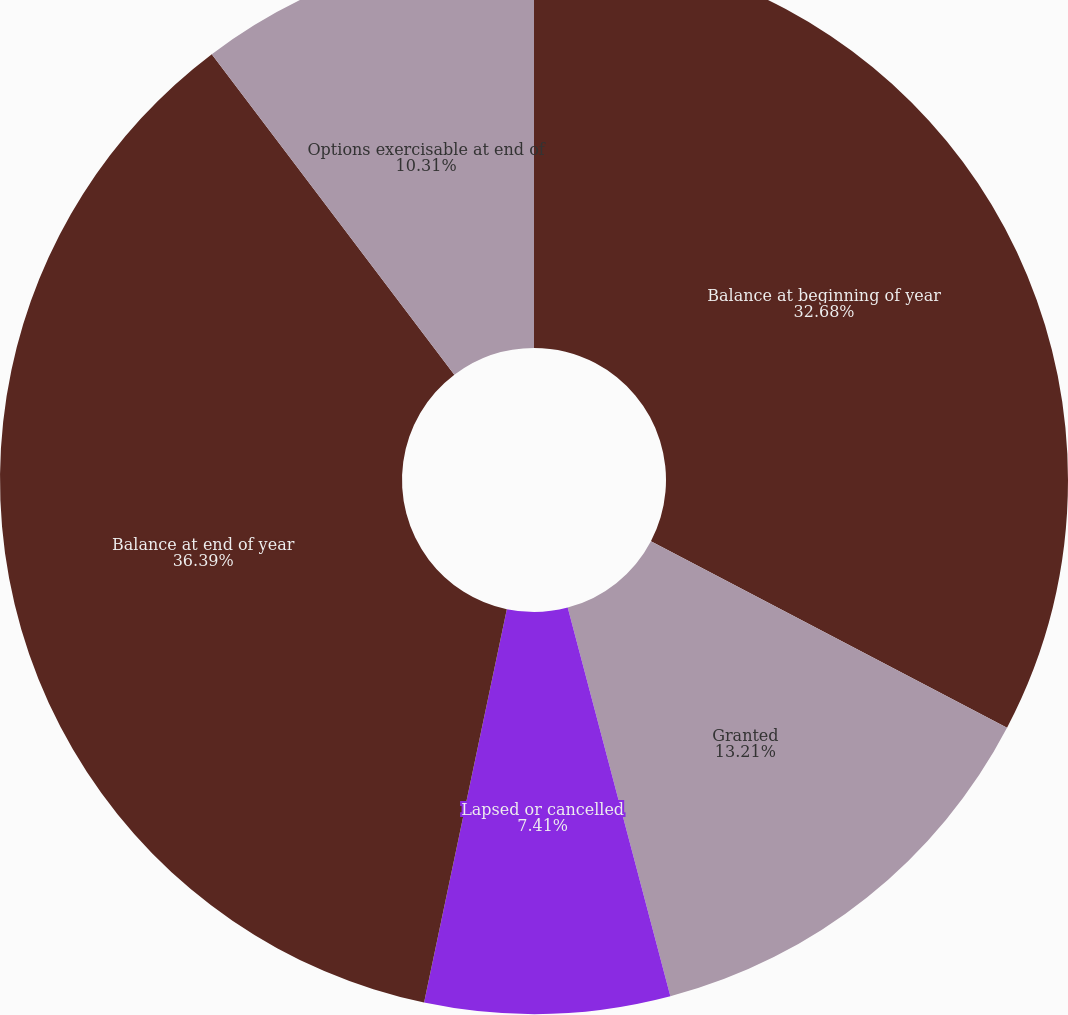<chart> <loc_0><loc_0><loc_500><loc_500><pie_chart><fcel>Balance at beginning of year<fcel>Granted<fcel>Lapsed or cancelled<fcel>Balance at end of year<fcel>Options exercisable at end of<nl><fcel>32.68%<fcel>13.21%<fcel>7.41%<fcel>36.39%<fcel>10.31%<nl></chart> 